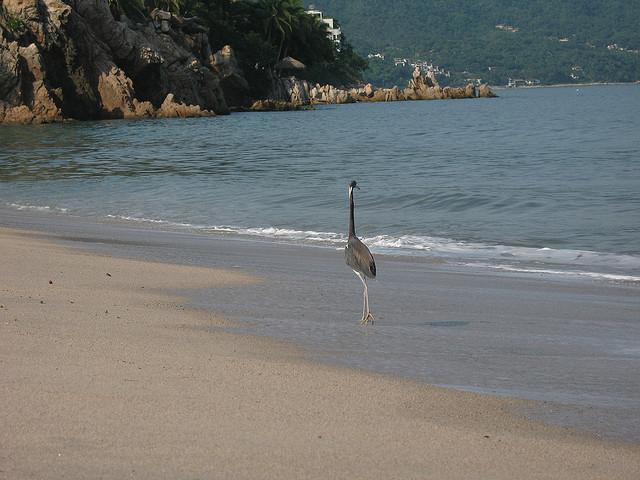What animal is on the beach?
Concise answer only. Heron. Is this a tall animal?
Short answer required. Yes. What kinds of animals are these?
Keep it brief. Bird. What number of feet imprints are in the sound?
Answer briefly. 0. Are there any trees in this photo?
Short answer required. Yes. How many birds are in the sky?
Short answer required. 0. On what beach was this picture taken?
Be succinct. Bird. 